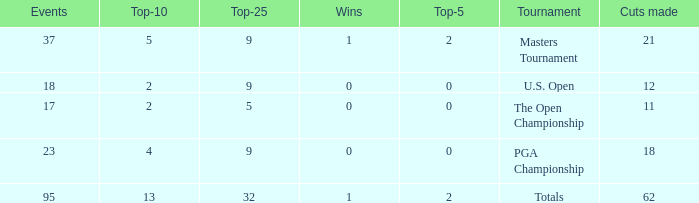What is the lowest top 5 winners with less than 0? None. 